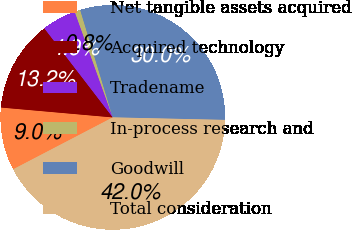Convert chart to OTSL. <chart><loc_0><loc_0><loc_500><loc_500><pie_chart><fcel>Net tangible assets acquired<fcel>Acquired technology<fcel>Tradename<fcel>In-process research and<fcel>Goodwill<fcel>Total consideration<nl><fcel>9.05%<fcel>13.17%<fcel>4.93%<fcel>0.81%<fcel>30.05%<fcel>42.0%<nl></chart> 